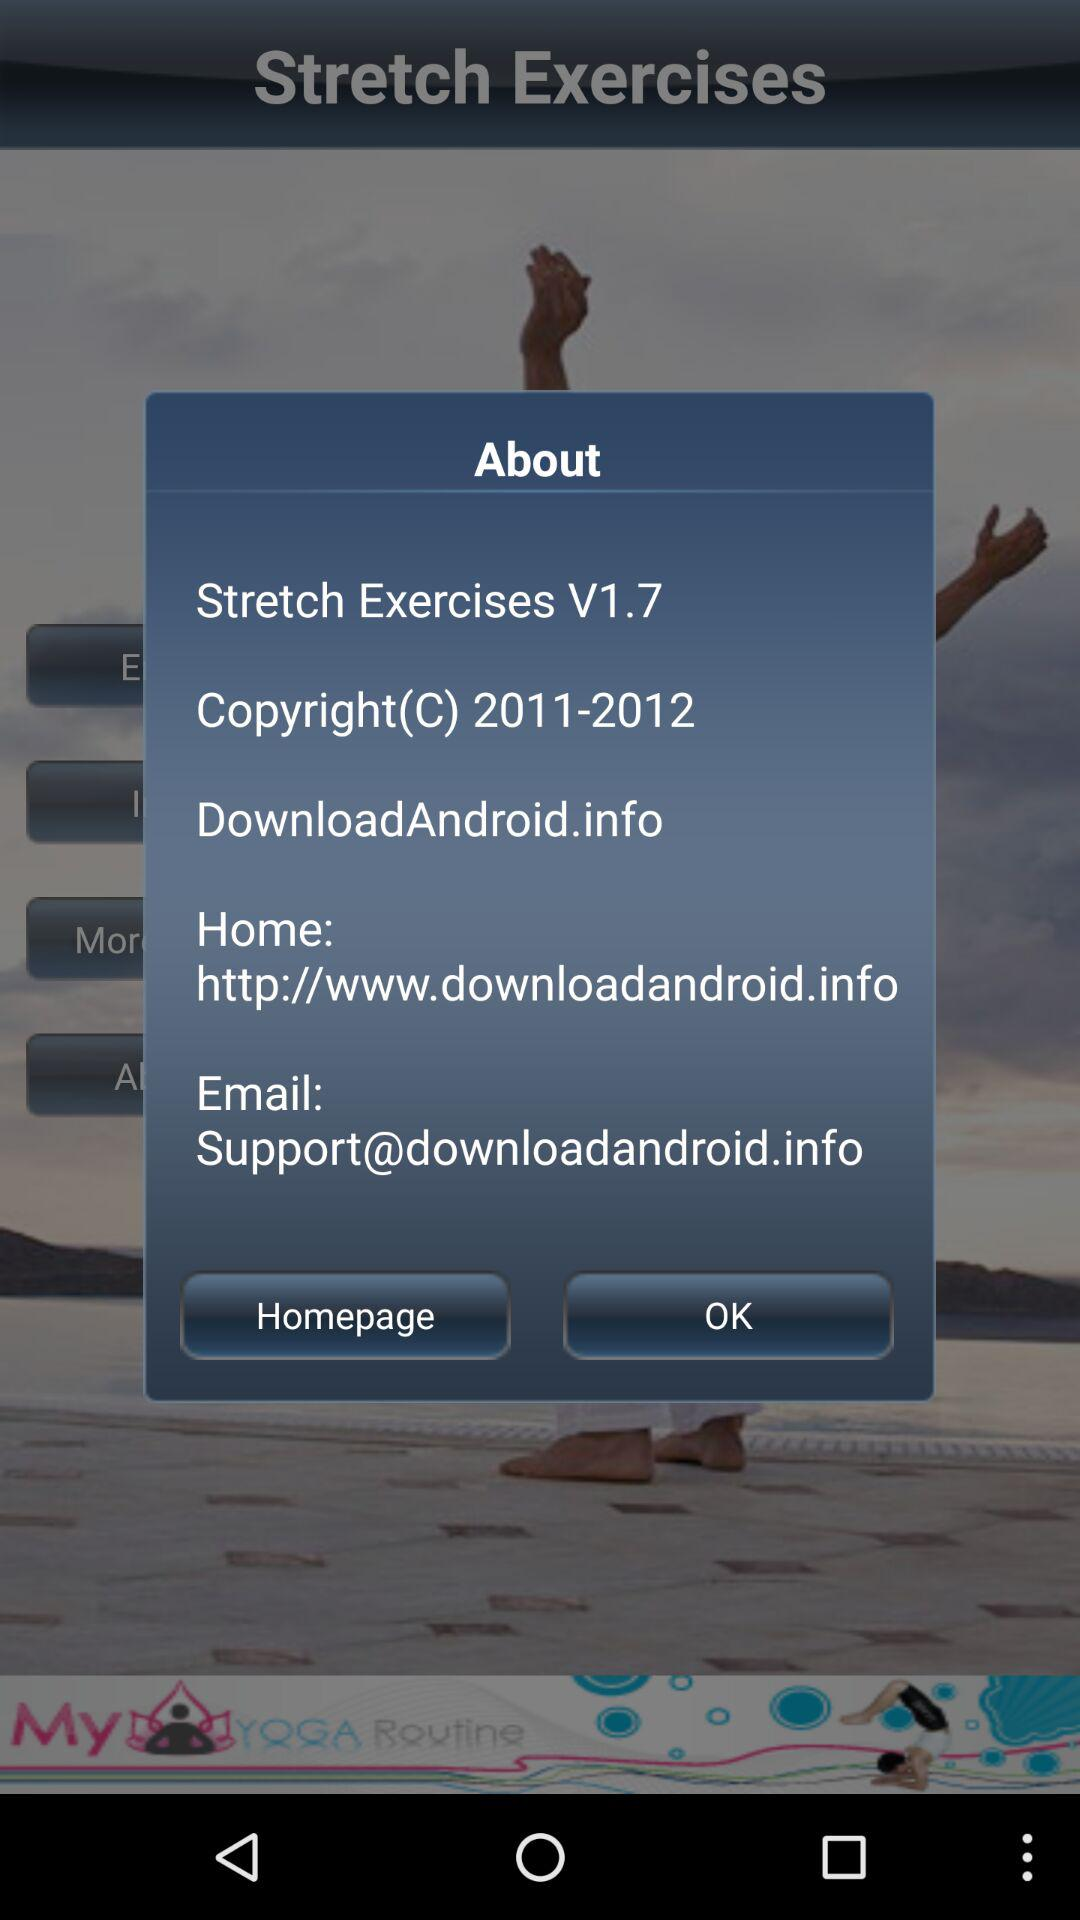What is the email address? The email address is Support@downloadandroid.info. 